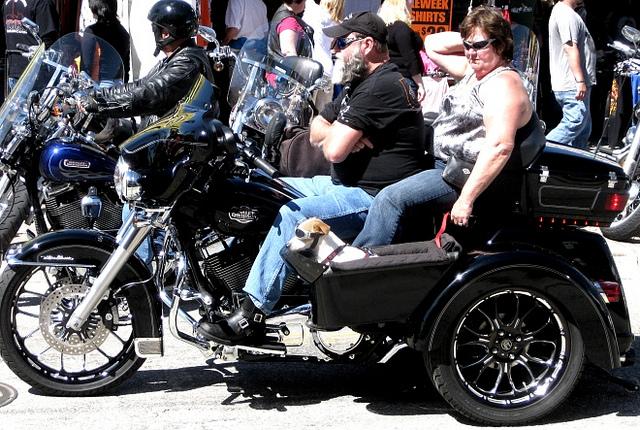Are these bikers?
Answer briefly. Yes. How many riders are on the black motorcycle?
Keep it brief. 2. What accessory is the bog wearing?
Concise answer only. Sunglasses. How many tires does the bike have?
Short answer required. 3. Is the female in the image large or small in size?
Short answer required. Large. 